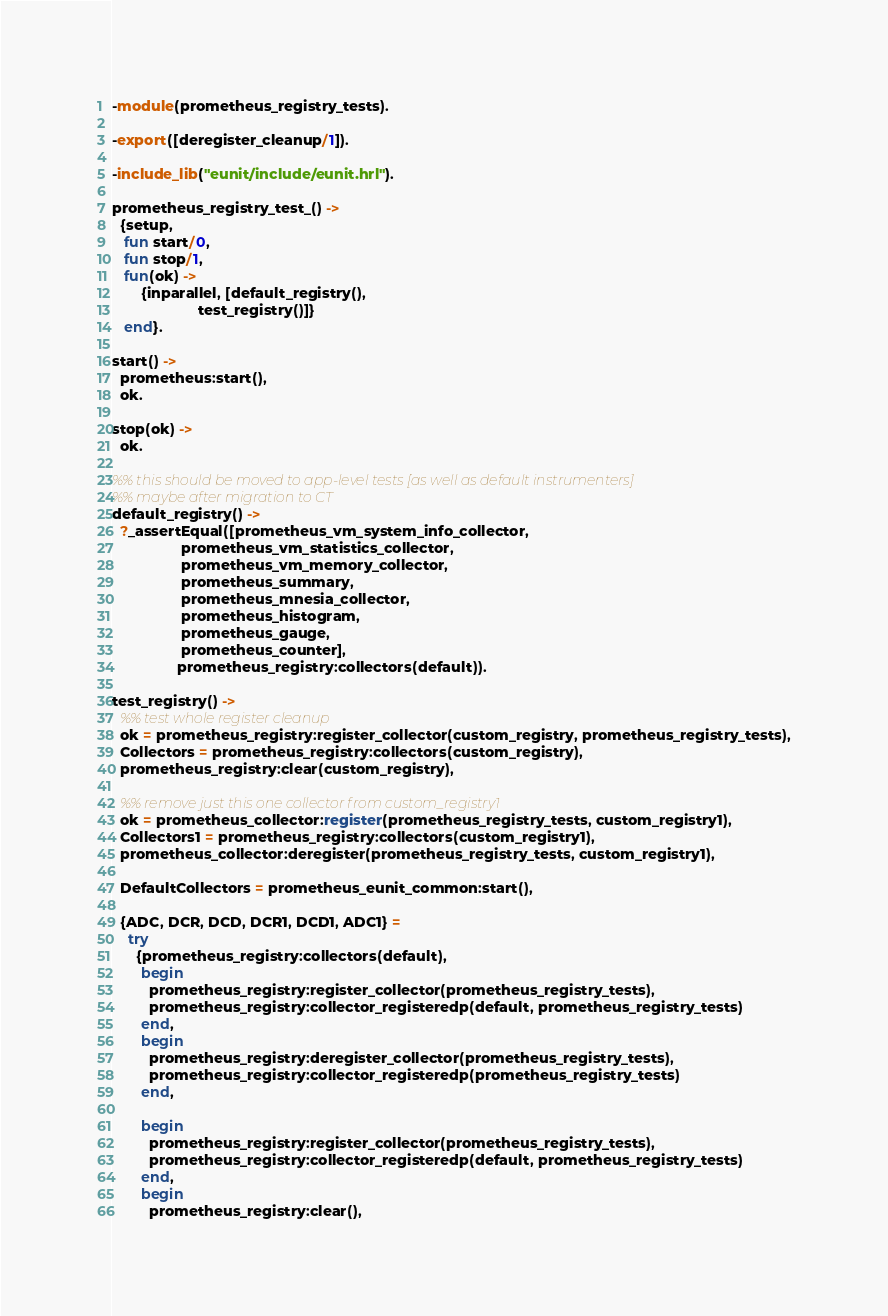<code> <loc_0><loc_0><loc_500><loc_500><_Erlang_>-module(prometheus_registry_tests).

-export([deregister_cleanup/1]).

-include_lib("eunit/include/eunit.hrl").

prometheus_registry_test_() ->
  {setup,
   fun start/0,
   fun stop/1,
   fun(ok) ->
       {inparallel, [default_registry(),
                     test_registry()]}
   end}.

start() ->
  prometheus:start(),
  ok.

stop(ok) ->
  ok.

%% this should be moved to app-level tests [as well as default instrumenters]
%% maybe after migration to CT
default_registry() ->
  ?_assertEqual([prometheus_vm_system_info_collector,
                 prometheus_vm_statistics_collector,
                 prometheus_vm_memory_collector,
                 prometheus_summary,
                 prometheus_mnesia_collector,
                 prometheus_histogram,
                 prometheus_gauge,
                 prometheus_counter],
                prometheus_registry:collectors(default)).

test_registry() ->
  %% test whole register cleanup
  ok = prometheus_registry:register_collector(custom_registry, prometheus_registry_tests),
  Collectors = prometheus_registry:collectors(custom_registry),
  prometheus_registry:clear(custom_registry),

  %% remove just this one collector from custom_registry1
  ok = prometheus_collector:register(prometheus_registry_tests, custom_registry1),
  Collectors1 = prometheus_registry:collectors(custom_registry1),
  prometheus_collector:deregister(prometheus_registry_tests, custom_registry1),

  DefaultCollectors = prometheus_eunit_common:start(),

  {ADC, DCR, DCD, DCR1, DCD1, ADC1} =
    try
      {prometheus_registry:collectors(default),
       begin
         prometheus_registry:register_collector(prometheus_registry_tests),
         prometheus_registry:collector_registeredp(default, prometheus_registry_tests)
       end,
       begin
         prometheus_registry:deregister_collector(prometheus_registry_tests),
         prometheus_registry:collector_registeredp(prometheus_registry_tests)
       end,

       begin
         prometheus_registry:register_collector(prometheus_registry_tests),
         prometheus_registry:collector_registeredp(default, prometheus_registry_tests)
       end,
       begin
         prometheus_registry:clear(),</code> 